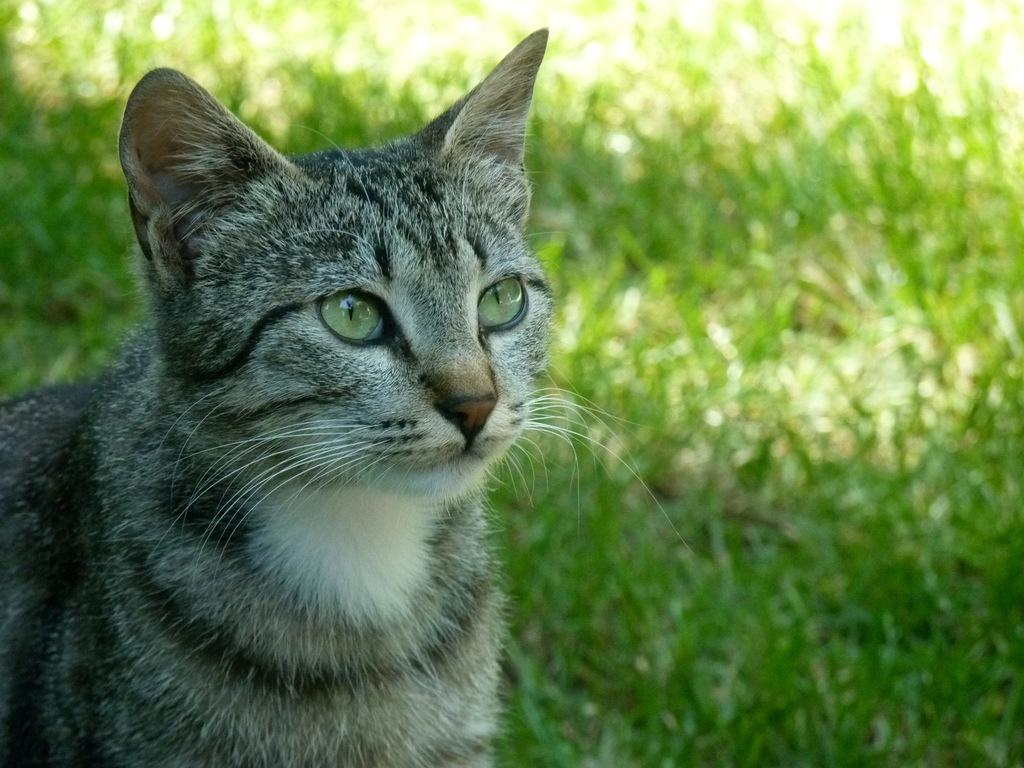What animal is located on the left side of the image? There is a cat on the left side of the image. What type of environment is visible in the background of the image? There is a grassy land in the background of the image. What type of rod does the cat need to gain approval from its partner in the image? There is no mention of a rod, approval, or partner in the image; it only features a cat and grassy land in the background. 